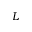Convert formula to latex. <formula><loc_0><loc_0><loc_500><loc_500>L</formula> 